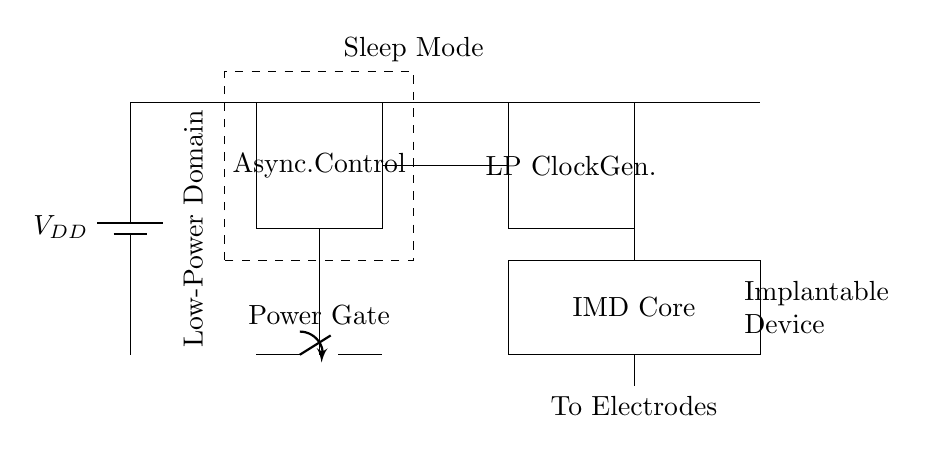What type of device is represented in the circuit diagram? The circuit diagram represents an implantable medical device, as indicated by the label in the diagram.
Answer: implantable medical device What is the function of the component labeled "LP Clock Gen"? The "LP Clock Gen" or low-power clock generator provides timing signals essential for the operation of the asynchronous control logic in the circuit.
Answer: generate timing signals How many components are indicated in the circuit diagram? There are four main components in the circuit: the battery, asynchronous control logic, low-power clock generator, and implantable medical device core.
Answer: four What is the role of the "Power Gate" in the circuit? The "Power Gate" acts as a switch that controls the power supply to the implantable medical device core, enabling low-power operation when necessary.
Answer: control power supply In which state does the dashed rectangle labeled "Sleep Mode" indicate the device operates? The dashed rectangle indicates that in the sleep mode, the device is in a low power state, minimizing energy consumption when it is not actively functioning.
Answer: low power state How does the asynchronous nature of the circuit benefit implantable medical devices? The asynchronous design allows for lower power operation and reduced complexity in timing management, which is crucial for extending battery life in implantable devices.
Answer: lower power operation What is the significance of the connection labeled "To Electrodes" in the diagram? The connection labeled "To Electrodes" denotes that the output of the implantable device will interface with electrodes, likely for stimulation or sensing physiological signals.
Answer: interface with electrodes 